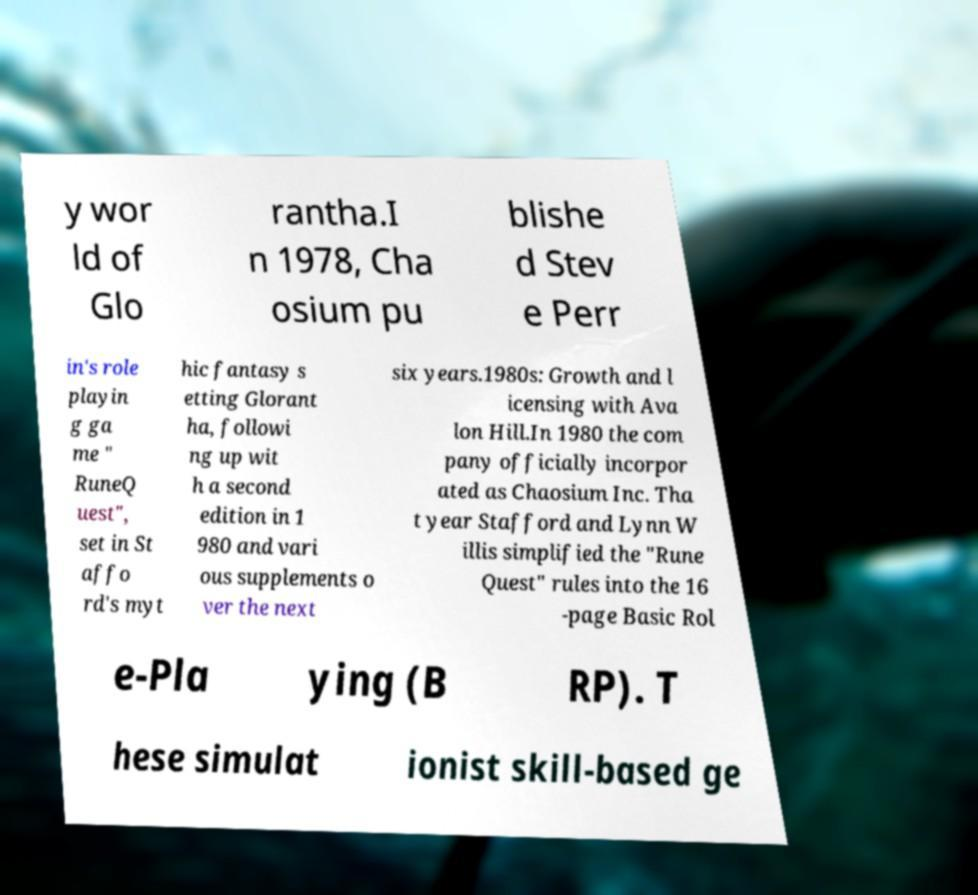Please read and relay the text visible in this image. What does it say? y wor ld of Glo rantha.I n 1978, Cha osium pu blishe d Stev e Perr in's role playin g ga me " RuneQ uest", set in St affo rd's myt hic fantasy s etting Glorant ha, followi ng up wit h a second edition in 1 980 and vari ous supplements o ver the next six years.1980s: Growth and l icensing with Ava lon Hill.In 1980 the com pany officially incorpor ated as Chaosium Inc. Tha t year Stafford and Lynn W illis simplified the "Rune Quest" rules into the 16 -page Basic Rol e-Pla ying (B RP). T hese simulat ionist skill-based ge 